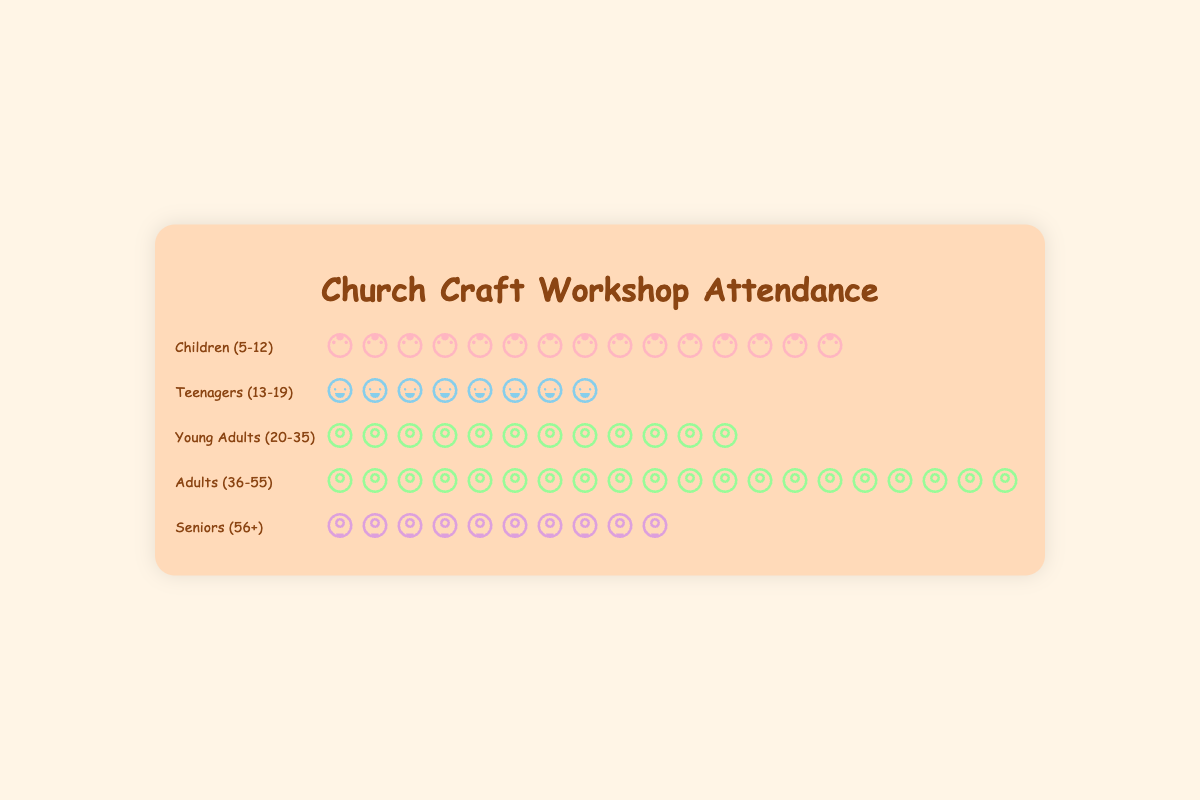What is the age group with the highest attendance? The figure shows that the "Adults (36-55)" age group has the most icons, indicating the highest attendance.
Answer: Adults (36-55) Which age group has the lowest attendance? By counting the icons, "Teenagers (13-19)" have the fewest, with only 8 icons.
Answer: Teenagers (13-19) How many more adults (36-55) attended compared to teenagers (13-19)? Adults (36-55) have 20 attendees, and Teenagers (13-19) have 8. The difference is 20 - 8 = 12.
Answer: 12 What is the total attendance of children (5-12) and seniors (56+)? Children (5-12) have 15 attendees and Seniors (56+) have 10. The total is 15 + 10 = 25.
Answer: 25 Which two age groups have the same type of icon, and what does it represent? The icons for "Young Adults (20-35)" and "Adults (36-55)" are the same, representing an adult figure.
Answer: Young Adults and Adults; adult figure How many participants in total attended the workshop? By summing the participants: Children (15) + Teenagers (8) + Young Adults (12) + Adults (20) + Seniors (10) = 65.
Answer: 65 What is the average attendance across all age groups? Total attendance is 65 spread across 5 age groups. The average attendance is 65 / 5 = 13.
Answer: 13 Are there more young adults (20-35) or seniors (56+)? Comparing the icons, Young Adults have 12 attendees, and Seniors have 10.
Answer: Young Adults How many more children (5-12) attended than young adults (20-35)? Children (5-12) have 15 attendees, Young Adults (20-35) have 12. The difference is 15 - 12 = 3.
Answer: 3 What is the ratio of adult (36-55) attendees to total attendees? There are 20 adults out of 65 total attendees. The ratio is 20 / 65, which simplifies approximately to 4 / 13.
Answer: 4/13 